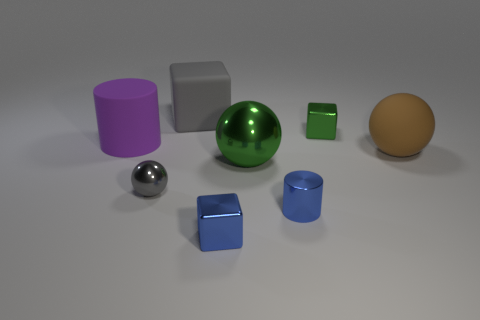Add 2 big purple objects. How many objects exist? 10 Subtract all spheres. How many objects are left? 5 Add 6 matte spheres. How many matte spheres are left? 7 Add 3 large green metal objects. How many large green metal objects exist? 4 Subtract 0 cyan balls. How many objects are left? 8 Subtract all large green objects. Subtract all large metal spheres. How many objects are left? 6 